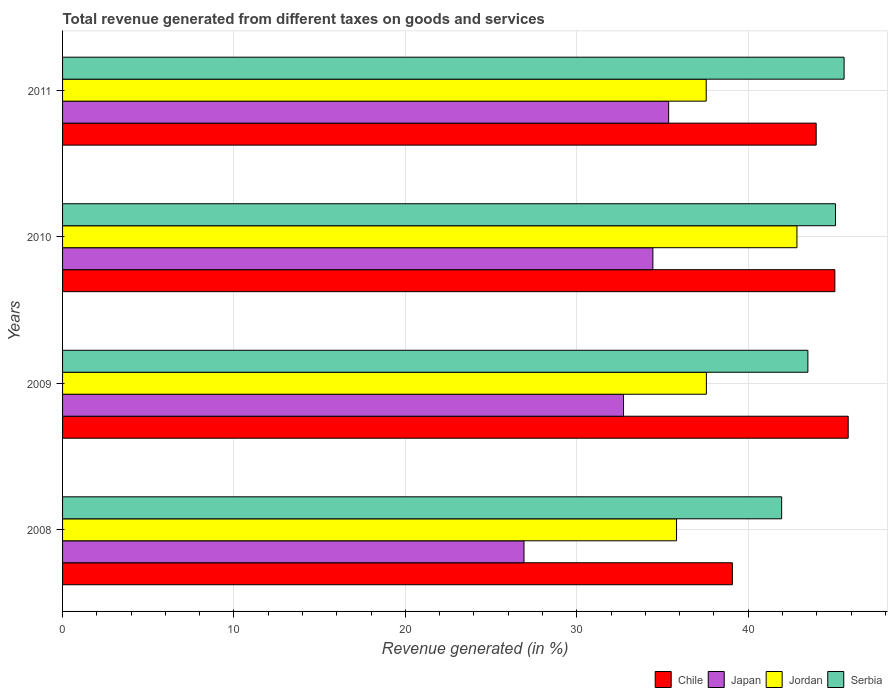How many groups of bars are there?
Keep it short and to the point. 4. Are the number of bars on each tick of the Y-axis equal?
Your answer should be compact. Yes. In how many cases, is the number of bars for a given year not equal to the number of legend labels?
Your response must be concise. 0. What is the total revenue generated in Japan in 2011?
Make the answer very short. 35.36. Across all years, what is the maximum total revenue generated in Japan?
Provide a succinct answer. 35.36. Across all years, what is the minimum total revenue generated in Jordan?
Your response must be concise. 35.82. In which year was the total revenue generated in Jordan maximum?
Your answer should be very brief. 2010. What is the total total revenue generated in Japan in the graph?
Keep it short and to the point. 129.45. What is the difference between the total revenue generated in Japan in 2009 and that in 2010?
Your answer should be compact. -1.71. What is the difference between the total revenue generated in Japan in 2010 and the total revenue generated in Jordan in 2011?
Your answer should be compact. -3.11. What is the average total revenue generated in Serbia per year?
Make the answer very short. 44.03. In the year 2008, what is the difference between the total revenue generated in Chile and total revenue generated in Serbia?
Your response must be concise. -2.88. What is the ratio of the total revenue generated in Japan in 2008 to that in 2010?
Your answer should be very brief. 0.78. Is the difference between the total revenue generated in Chile in 2009 and 2010 greater than the difference between the total revenue generated in Serbia in 2009 and 2010?
Give a very brief answer. Yes. What is the difference between the highest and the second highest total revenue generated in Jordan?
Make the answer very short. 5.28. What is the difference between the highest and the lowest total revenue generated in Serbia?
Ensure brevity in your answer.  3.64. In how many years, is the total revenue generated in Jordan greater than the average total revenue generated in Jordan taken over all years?
Ensure brevity in your answer.  1. What does the 2nd bar from the top in 2008 represents?
Your answer should be very brief. Jordan. Are all the bars in the graph horizontal?
Provide a short and direct response. Yes. What is the difference between two consecutive major ticks on the X-axis?
Offer a terse response. 10. Are the values on the major ticks of X-axis written in scientific E-notation?
Your answer should be very brief. No. Where does the legend appear in the graph?
Your answer should be compact. Bottom right. What is the title of the graph?
Offer a terse response. Total revenue generated from different taxes on goods and services. Does "Latin America(developing only)" appear as one of the legend labels in the graph?
Your response must be concise. No. What is the label or title of the X-axis?
Offer a very short reply. Revenue generated (in %). What is the Revenue generated (in %) of Chile in 2008?
Provide a succinct answer. 39.08. What is the Revenue generated (in %) of Japan in 2008?
Ensure brevity in your answer.  26.92. What is the Revenue generated (in %) of Jordan in 2008?
Ensure brevity in your answer.  35.82. What is the Revenue generated (in %) in Serbia in 2008?
Offer a terse response. 41.95. What is the Revenue generated (in %) of Chile in 2009?
Keep it short and to the point. 45.84. What is the Revenue generated (in %) in Japan in 2009?
Ensure brevity in your answer.  32.73. What is the Revenue generated (in %) in Jordan in 2009?
Provide a succinct answer. 37.56. What is the Revenue generated (in %) in Serbia in 2009?
Keep it short and to the point. 43.49. What is the Revenue generated (in %) in Chile in 2010?
Keep it short and to the point. 45.06. What is the Revenue generated (in %) in Japan in 2010?
Make the answer very short. 34.44. What is the Revenue generated (in %) in Jordan in 2010?
Keep it short and to the point. 42.85. What is the Revenue generated (in %) of Serbia in 2010?
Keep it short and to the point. 45.09. What is the Revenue generated (in %) in Chile in 2011?
Provide a short and direct response. 43.97. What is the Revenue generated (in %) of Japan in 2011?
Ensure brevity in your answer.  35.36. What is the Revenue generated (in %) in Jordan in 2011?
Ensure brevity in your answer.  37.55. What is the Revenue generated (in %) of Serbia in 2011?
Provide a succinct answer. 45.6. Across all years, what is the maximum Revenue generated (in %) of Chile?
Ensure brevity in your answer.  45.84. Across all years, what is the maximum Revenue generated (in %) of Japan?
Your answer should be compact. 35.36. Across all years, what is the maximum Revenue generated (in %) of Jordan?
Keep it short and to the point. 42.85. Across all years, what is the maximum Revenue generated (in %) of Serbia?
Offer a terse response. 45.6. Across all years, what is the minimum Revenue generated (in %) in Chile?
Give a very brief answer. 39.08. Across all years, what is the minimum Revenue generated (in %) of Japan?
Your answer should be compact. 26.92. Across all years, what is the minimum Revenue generated (in %) of Jordan?
Your answer should be compact. 35.82. Across all years, what is the minimum Revenue generated (in %) in Serbia?
Provide a short and direct response. 41.95. What is the total Revenue generated (in %) of Chile in the graph?
Your answer should be compact. 173.94. What is the total Revenue generated (in %) of Japan in the graph?
Make the answer very short. 129.45. What is the total Revenue generated (in %) of Jordan in the graph?
Your answer should be very brief. 153.78. What is the total Revenue generated (in %) of Serbia in the graph?
Give a very brief answer. 176.13. What is the difference between the Revenue generated (in %) in Chile in 2008 and that in 2009?
Your answer should be very brief. -6.76. What is the difference between the Revenue generated (in %) of Japan in 2008 and that in 2009?
Give a very brief answer. -5.81. What is the difference between the Revenue generated (in %) of Jordan in 2008 and that in 2009?
Make the answer very short. -1.74. What is the difference between the Revenue generated (in %) of Serbia in 2008 and that in 2009?
Offer a terse response. -1.53. What is the difference between the Revenue generated (in %) of Chile in 2008 and that in 2010?
Give a very brief answer. -5.98. What is the difference between the Revenue generated (in %) in Japan in 2008 and that in 2010?
Your answer should be compact. -7.52. What is the difference between the Revenue generated (in %) in Jordan in 2008 and that in 2010?
Your answer should be very brief. -7.02. What is the difference between the Revenue generated (in %) in Serbia in 2008 and that in 2010?
Keep it short and to the point. -3.14. What is the difference between the Revenue generated (in %) in Chile in 2008 and that in 2011?
Offer a very short reply. -4.89. What is the difference between the Revenue generated (in %) of Japan in 2008 and that in 2011?
Keep it short and to the point. -8.44. What is the difference between the Revenue generated (in %) in Jordan in 2008 and that in 2011?
Your response must be concise. -1.73. What is the difference between the Revenue generated (in %) of Serbia in 2008 and that in 2011?
Give a very brief answer. -3.64. What is the difference between the Revenue generated (in %) of Chile in 2009 and that in 2010?
Your answer should be compact. 0.78. What is the difference between the Revenue generated (in %) in Japan in 2009 and that in 2010?
Offer a terse response. -1.71. What is the difference between the Revenue generated (in %) in Jordan in 2009 and that in 2010?
Your answer should be compact. -5.28. What is the difference between the Revenue generated (in %) of Serbia in 2009 and that in 2010?
Provide a succinct answer. -1.61. What is the difference between the Revenue generated (in %) of Chile in 2009 and that in 2011?
Offer a very short reply. 1.87. What is the difference between the Revenue generated (in %) in Japan in 2009 and that in 2011?
Provide a short and direct response. -2.63. What is the difference between the Revenue generated (in %) in Jordan in 2009 and that in 2011?
Ensure brevity in your answer.  0.01. What is the difference between the Revenue generated (in %) in Serbia in 2009 and that in 2011?
Keep it short and to the point. -2.11. What is the difference between the Revenue generated (in %) of Chile in 2010 and that in 2011?
Ensure brevity in your answer.  1.09. What is the difference between the Revenue generated (in %) in Japan in 2010 and that in 2011?
Give a very brief answer. -0.92. What is the difference between the Revenue generated (in %) of Jordan in 2010 and that in 2011?
Ensure brevity in your answer.  5.29. What is the difference between the Revenue generated (in %) of Serbia in 2010 and that in 2011?
Provide a short and direct response. -0.5. What is the difference between the Revenue generated (in %) in Chile in 2008 and the Revenue generated (in %) in Japan in 2009?
Keep it short and to the point. 6.35. What is the difference between the Revenue generated (in %) of Chile in 2008 and the Revenue generated (in %) of Jordan in 2009?
Keep it short and to the point. 1.52. What is the difference between the Revenue generated (in %) in Chile in 2008 and the Revenue generated (in %) in Serbia in 2009?
Provide a short and direct response. -4.41. What is the difference between the Revenue generated (in %) of Japan in 2008 and the Revenue generated (in %) of Jordan in 2009?
Give a very brief answer. -10.64. What is the difference between the Revenue generated (in %) in Japan in 2008 and the Revenue generated (in %) in Serbia in 2009?
Give a very brief answer. -16.56. What is the difference between the Revenue generated (in %) of Jordan in 2008 and the Revenue generated (in %) of Serbia in 2009?
Keep it short and to the point. -7.66. What is the difference between the Revenue generated (in %) in Chile in 2008 and the Revenue generated (in %) in Japan in 2010?
Your answer should be compact. 4.64. What is the difference between the Revenue generated (in %) in Chile in 2008 and the Revenue generated (in %) in Jordan in 2010?
Offer a very short reply. -3.77. What is the difference between the Revenue generated (in %) of Chile in 2008 and the Revenue generated (in %) of Serbia in 2010?
Your answer should be compact. -6.02. What is the difference between the Revenue generated (in %) of Japan in 2008 and the Revenue generated (in %) of Jordan in 2010?
Provide a short and direct response. -15.92. What is the difference between the Revenue generated (in %) in Japan in 2008 and the Revenue generated (in %) in Serbia in 2010?
Offer a terse response. -18.17. What is the difference between the Revenue generated (in %) in Jordan in 2008 and the Revenue generated (in %) in Serbia in 2010?
Make the answer very short. -9.27. What is the difference between the Revenue generated (in %) of Chile in 2008 and the Revenue generated (in %) of Japan in 2011?
Ensure brevity in your answer.  3.72. What is the difference between the Revenue generated (in %) in Chile in 2008 and the Revenue generated (in %) in Jordan in 2011?
Your answer should be compact. 1.52. What is the difference between the Revenue generated (in %) of Chile in 2008 and the Revenue generated (in %) of Serbia in 2011?
Your answer should be compact. -6.52. What is the difference between the Revenue generated (in %) of Japan in 2008 and the Revenue generated (in %) of Jordan in 2011?
Provide a succinct answer. -10.63. What is the difference between the Revenue generated (in %) of Japan in 2008 and the Revenue generated (in %) of Serbia in 2011?
Your response must be concise. -18.68. What is the difference between the Revenue generated (in %) of Jordan in 2008 and the Revenue generated (in %) of Serbia in 2011?
Your answer should be very brief. -9.78. What is the difference between the Revenue generated (in %) in Chile in 2009 and the Revenue generated (in %) in Japan in 2010?
Your answer should be compact. 11.4. What is the difference between the Revenue generated (in %) in Chile in 2009 and the Revenue generated (in %) in Jordan in 2010?
Your answer should be very brief. 2.99. What is the difference between the Revenue generated (in %) of Chile in 2009 and the Revenue generated (in %) of Serbia in 2010?
Provide a short and direct response. 0.74. What is the difference between the Revenue generated (in %) in Japan in 2009 and the Revenue generated (in %) in Jordan in 2010?
Your answer should be compact. -10.12. What is the difference between the Revenue generated (in %) of Japan in 2009 and the Revenue generated (in %) of Serbia in 2010?
Offer a very short reply. -12.37. What is the difference between the Revenue generated (in %) of Jordan in 2009 and the Revenue generated (in %) of Serbia in 2010?
Keep it short and to the point. -7.53. What is the difference between the Revenue generated (in %) in Chile in 2009 and the Revenue generated (in %) in Japan in 2011?
Keep it short and to the point. 10.48. What is the difference between the Revenue generated (in %) of Chile in 2009 and the Revenue generated (in %) of Jordan in 2011?
Provide a short and direct response. 8.28. What is the difference between the Revenue generated (in %) of Chile in 2009 and the Revenue generated (in %) of Serbia in 2011?
Your answer should be very brief. 0.24. What is the difference between the Revenue generated (in %) in Japan in 2009 and the Revenue generated (in %) in Jordan in 2011?
Offer a very short reply. -4.83. What is the difference between the Revenue generated (in %) of Japan in 2009 and the Revenue generated (in %) of Serbia in 2011?
Provide a succinct answer. -12.87. What is the difference between the Revenue generated (in %) in Jordan in 2009 and the Revenue generated (in %) in Serbia in 2011?
Keep it short and to the point. -8.03. What is the difference between the Revenue generated (in %) of Chile in 2010 and the Revenue generated (in %) of Japan in 2011?
Ensure brevity in your answer.  9.7. What is the difference between the Revenue generated (in %) in Chile in 2010 and the Revenue generated (in %) in Jordan in 2011?
Ensure brevity in your answer.  7.51. What is the difference between the Revenue generated (in %) of Chile in 2010 and the Revenue generated (in %) of Serbia in 2011?
Your answer should be compact. -0.54. What is the difference between the Revenue generated (in %) of Japan in 2010 and the Revenue generated (in %) of Jordan in 2011?
Ensure brevity in your answer.  -3.11. What is the difference between the Revenue generated (in %) in Japan in 2010 and the Revenue generated (in %) in Serbia in 2011?
Your response must be concise. -11.16. What is the difference between the Revenue generated (in %) in Jordan in 2010 and the Revenue generated (in %) in Serbia in 2011?
Ensure brevity in your answer.  -2.75. What is the average Revenue generated (in %) in Chile per year?
Keep it short and to the point. 43.49. What is the average Revenue generated (in %) in Japan per year?
Make the answer very short. 32.36. What is the average Revenue generated (in %) in Jordan per year?
Your response must be concise. 38.45. What is the average Revenue generated (in %) in Serbia per year?
Offer a very short reply. 44.03. In the year 2008, what is the difference between the Revenue generated (in %) of Chile and Revenue generated (in %) of Japan?
Make the answer very short. 12.16. In the year 2008, what is the difference between the Revenue generated (in %) in Chile and Revenue generated (in %) in Jordan?
Your answer should be compact. 3.26. In the year 2008, what is the difference between the Revenue generated (in %) in Chile and Revenue generated (in %) in Serbia?
Offer a very short reply. -2.88. In the year 2008, what is the difference between the Revenue generated (in %) in Japan and Revenue generated (in %) in Jordan?
Offer a terse response. -8.9. In the year 2008, what is the difference between the Revenue generated (in %) in Japan and Revenue generated (in %) in Serbia?
Make the answer very short. -15.03. In the year 2008, what is the difference between the Revenue generated (in %) in Jordan and Revenue generated (in %) in Serbia?
Make the answer very short. -6.13. In the year 2009, what is the difference between the Revenue generated (in %) of Chile and Revenue generated (in %) of Japan?
Your answer should be very brief. 13.11. In the year 2009, what is the difference between the Revenue generated (in %) in Chile and Revenue generated (in %) in Jordan?
Provide a short and direct response. 8.27. In the year 2009, what is the difference between the Revenue generated (in %) of Chile and Revenue generated (in %) of Serbia?
Your answer should be compact. 2.35. In the year 2009, what is the difference between the Revenue generated (in %) in Japan and Revenue generated (in %) in Jordan?
Your answer should be compact. -4.83. In the year 2009, what is the difference between the Revenue generated (in %) of Japan and Revenue generated (in %) of Serbia?
Provide a short and direct response. -10.76. In the year 2009, what is the difference between the Revenue generated (in %) of Jordan and Revenue generated (in %) of Serbia?
Offer a very short reply. -5.92. In the year 2010, what is the difference between the Revenue generated (in %) in Chile and Revenue generated (in %) in Japan?
Keep it short and to the point. 10.62. In the year 2010, what is the difference between the Revenue generated (in %) of Chile and Revenue generated (in %) of Jordan?
Keep it short and to the point. 2.21. In the year 2010, what is the difference between the Revenue generated (in %) in Chile and Revenue generated (in %) in Serbia?
Provide a short and direct response. -0.04. In the year 2010, what is the difference between the Revenue generated (in %) in Japan and Revenue generated (in %) in Jordan?
Offer a terse response. -8.41. In the year 2010, what is the difference between the Revenue generated (in %) in Japan and Revenue generated (in %) in Serbia?
Provide a succinct answer. -10.65. In the year 2010, what is the difference between the Revenue generated (in %) of Jordan and Revenue generated (in %) of Serbia?
Your answer should be very brief. -2.25. In the year 2011, what is the difference between the Revenue generated (in %) in Chile and Revenue generated (in %) in Japan?
Offer a terse response. 8.61. In the year 2011, what is the difference between the Revenue generated (in %) in Chile and Revenue generated (in %) in Jordan?
Your answer should be compact. 6.42. In the year 2011, what is the difference between the Revenue generated (in %) of Chile and Revenue generated (in %) of Serbia?
Your answer should be compact. -1.63. In the year 2011, what is the difference between the Revenue generated (in %) in Japan and Revenue generated (in %) in Jordan?
Make the answer very short. -2.19. In the year 2011, what is the difference between the Revenue generated (in %) in Japan and Revenue generated (in %) in Serbia?
Keep it short and to the point. -10.24. In the year 2011, what is the difference between the Revenue generated (in %) in Jordan and Revenue generated (in %) in Serbia?
Make the answer very short. -8.04. What is the ratio of the Revenue generated (in %) in Chile in 2008 to that in 2009?
Provide a succinct answer. 0.85. What is the ratio of the Revenue generated (in %) in Japan in 2008 to that in 2009?
Ensure brevity in your answer.  0.82. What is the ratio of the Revenue generated (in %) of Jordan in 2008 to that in 2009?
Provide a short and direct response. 0.95. What is the ratio of the Revenue generated (in %) of Serbia in 2008 to that in 2009?
Ensure brevity in your answer.  0.96. What is the ratio of the Revenue generated (in %) of Chile in 2008 to that in 2010?
Provide a succinct answer. 0.87. What is the ratio of the Revenue generated (in %) in Japan in 2008 to that in 2010?
Give a very brief answer. 0.78. What is the ratio of the Revenue generated (in %) in Jordan in 2008 to that in 2010?
Provide a short and direct response. 0.84. What is the ratio of the Revenue generated (in %) of Serbia in 2008 to that in 2010?
Give a very brief answer. 0.93. What is the ratio of the Revenue generated (in %) in Chile in 2008 to that in 2011?
Offer a very short reply. 0.89. What is the ratio of the Revenue generated (in %) of Japan in 2008 to that in 2011?
Ensure brevity in your answer.  0.76. What is the ratio of the Revenue generated (in %) of Jordan in 2008 to that in 2011?
Keep it short and to the point. 0.95. What is the ratio of the Revenue generated (in %) of Serbia in 2008 to that in 2011?
Offer a very short reply. 0.92. What is the ratio of the Revenue generated (in %) in Chile in 2009 to that in 2010?
Your answer should be compact. 1.02. What is the ratio of the Revenue generated (in %) in Japan in 2009 to that in 2010?
Offer a very short reply. 0.95. What is the ratio of the Revenue generated (in %) of Jordan in 2009 to that in 2010?
Offer a very short reply. 0.88. What is the ratio of the Revenue generated (in %) of Chile in 2009 to that in 2011?
Your answer should be compact. 1.04. What is the ratio of the Revenue generated (in %) of Japan in 2009 to that in 2011?
Your answer should be compact. 0.93. What is the ratio of the Revenue generated (in %) in Serbia in 2009 to that in 2011?
Your answer should be compact. 0.95. What is the ratio of the Revenue generated (in %) in Chile in 2010 to that in 2011?
Keep it short and to the point. 1.02. What is the ratio of the Revenue generated (in %) of Jordan in 2010 to that in 2011?
Ensure brevity in your answer.  1.14. What is the ratio of the Revenue generated (in %) of Serbia in 2010 to that in 2011?
Make the answer very short. 0.99. What is the difference between the highest and the second highest Revenue generated (in %) in Chile?
Offer a very short reply. 0.78. What is the difference between the highest and the second highest Revenue generated (in %) of Japan?
Your answer should be very brief. 0.92. What is the difference between the highest and the second highest Revenue generated (in %) in Jordan?
Ensure brevity in your answer.  5.28. What is the difference between the highest and the second highest Revenue generated (in %) of Serbia?
Your answer should be compact. 0.5. What is the difference between the highest and the lowest Revenue generated (in %) in Chile?
Your answer should be very brief. 6.76. What is the difference between the highest and the lowest Revenue generated (in %) in Japan?
Keep it short and to the point. 8.44. What is the difference between the highest and the lowest Revenue generated (in %) of Jordan?
Keep it short and to the point. 7.02. What is the difference between the highest and the lowest Revenue generated (in %) of Serbia?
Keep it short and to the point. 3.64. 